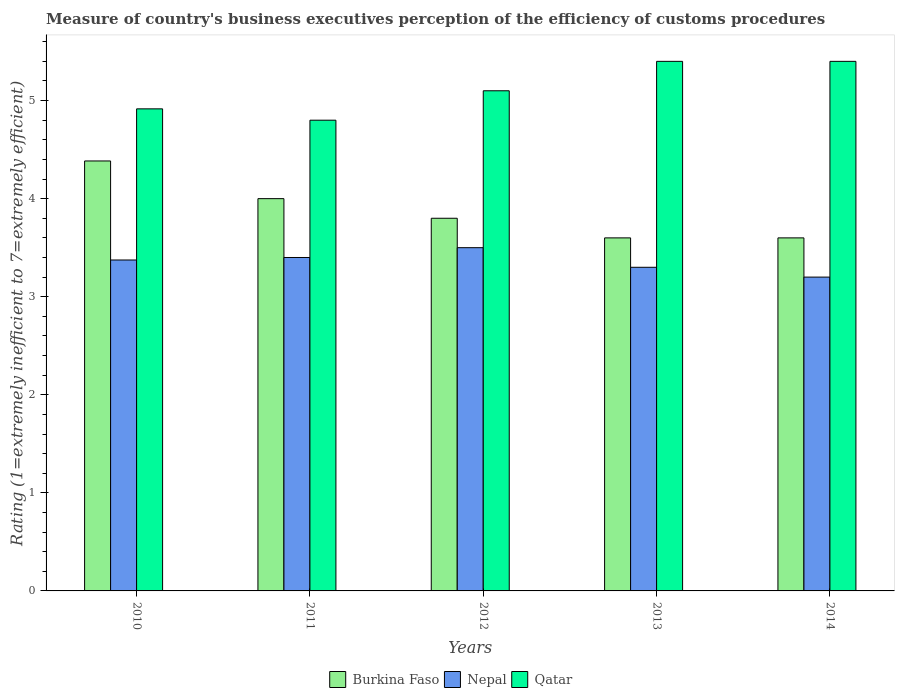How many groups of bars are there?
Provide a short and direct response. 5. How many bars are there on the 5th tick from the left?
Provide a succinct answer. 3. What is the label of the 4th group of bars from the left?
Offer a very short reply. 2013. Across all years, what is the maximum rating of the efficiency of customs procedure in Nepal?
Provide a succinct answer. 3.5. In which year was the rating of the efficiency of customs procedure in Burkina Faso maximum?
Keep it short and to the point. 2010. In which year was the rating of the efficiency of customs procedure in Qatar minimum?
Give a very brief answer. 2011. What is the total rating of the efficiency of customs procedure in Nepal in the graph?
Offer a terse response. 16.77. What is the difference between the rating of the efficiency of customs procedure in Qatar in 2011 and that in 2012?
Keep it short and to the point. -0.3. What is the difference between the rating of the efficiency of customs procedure in Qatar in 2011 and the rating of the efficiency of customs procedure in Nepal in 2010?
Ensure brevity in your answer.  1.43. What is the average rating of the efficiency of customs procedure in Qatar per year?
Your answer should be compact. 5.12. What is the ratio of the rating of the efficiency of customs procedure in Qatar in 2012 to that in 2014?
Offer a terse response. 0.94. Is the rating of the efficiency of customs procedure in Nepal in 2010 less than that in 2014?
Keep it short and to the point. No. Is the difference between the rating of the efficiency of customs procedure in Qatar in 2010 and 2013 greater than the difference between the rating of the efficiency of customs procedure in Nepal in 2010 and 2013?
Give a very brief answer. No. What is the difference between the highest and the second highest rating of the efficiency of customs procedure in Nepal?
Offer a very short reply. 0.1. What is the difference between the highest and the lowest rating of the efficiency of customs procedure in Burkina Faso?
Offer a terse response. 0.78. Is the sum of the rating of the efficiency of customs procedure in Nepal in 2010 and 2013 greater than the maximum rating of the efficiency of customs procedure in Burkina Faso across all years?
Provide a short and direct response. Yes. What does the 1st bar from the left in 2013 represents?
Give a very brief answer. Burkina Faso. What does the 3rd bar from the right in 2013 represents?
Give a very brief answer. Burkina Faso. Is it the case that in every year, the sum of the rating of the efficiency of customs procedure in Nepal and rating of the efficiency of customs procedure in Burkina Faso is greater than the rating of the efficiency of customs procedure in Qatar?
Give a very brief answer. Yes. How many bars are there?
Offer a terse response. 15. Are all the bars in the graph horizontal?
Make the answer very short. No. Are the values on the major ticks of Y-axis written in scientific E-notation?
Your answer should be compact. No. Does the graph contain grids?
Offer a very short reply. No. Where does the legend appear in the graph?
Your answer should be compact. Bottom center. How many legend labels are there?
Offer a terse response. 3. What is the title of the graph?
Your answer should be very brief. Measure of country's business executives perception of the efficiency of customs procedures. What is the label or title of the X-axis?
Your answer should be compact. Years. What is the label or title of the Y-axis?
Offer a terse response. Rating (1=extremely inefficient to 7=extremely efficient). What is the Rating (1=extremely inefficient to 7=extremely efficient) of Burkina Faso in 2010?
Give a very brief answer. 4.38. What is the Rating (1=extremely inefficient to 7=extremely efficient) of Nepal in 2010?
Provide a short and direct response. 3.37. What is the Rating (1=extremely inefficient to 7=extremely efficient) of Qatar in 2010?
Provide a short and direct response. 4.92. What is the Rating (1=extremely inefficient to 7=extremely efficient) in Burkina Faso in 2011?
Make the answer very short. 4. What is the Rating (1=extremely inefficient to 7=extremely efficient) in Nepal in 2011?
Ensure brevity in your answer.  3.4. What is the Rating (1=extremely inefficient to 7=extremely efficient) in Qatar in 2011?
Offer a very short reply. 4.8. What is the Rating (1=extremely inefficient to 7=extremely efficient) in Burkina Faso in 2012?
Your answer should be compact. 3.8. What is the Rating (1=extremely inefficient to 7=extremely efficient) in Nepal in 2012?
Keep it short and to the point. 3.5. What is the Rating (1=extremely inefficient to 7=extremely efficient) in Qatar in 2012?
Your answer should be very brief. 5.1. What is the Rating (1=extremely inefficient to 7=extremely efficient) of Qatar in 2013?
Your answer should be very brief. 5.4. What is the Rating (1=extremely inefficient to 7=extremely efficient) in Qatar in 2014?
Provide a short and direct response. 5.4. Across all years, what is the maximum Rating (1=extremely inefficient to 7=extremely efficient) of Burkina Faso?
Offer a terse response. 4.38. Across all years, what is the maximum Rating (1=extremely inefficient to 7=extremely efficient) of Nepal?
Keep it short and to the point. 3.5. Across all years, what is the maximum Rating (1=extremely inefficient to 7=extremely efficient) in Qatar?
Ensure brevity in your answer.  5.4. Across all years, what is the minimum Rating (1=extremely inefficient to 7=extremely efficient) of Qatar?
Your answer should be very brief. 4.8. What is the total Rating (1=extremely inefficient to 7=extremely efficient) in Burkina Faso in the graph?
Ensure brevity in your answer.  19.38. What is the total Rating (1=extremely inefficient to 7=extremely efficient) of Nepal in the graph?
Give a very brief answer. 16.77. What is the total Rating (1=extremely inefficient to 7=extremely efficient) of Qatar in the graph?
Provide a short and direct response. 25.62. What is the difference between the Rating (1=extremely inefficient to 7=extremely efficient) of Burkina Faso in 2010 and that in 2011?
Keep it short and to the point. 0.38. What is the difference between the Rating (1=extremely inefficient to 7=extremely efficient) in Nepal in 2010 and that in 2011?
Make the answer very short. -0.03. What is the difference between the Rating (1=extremely inefficient to 7=extremely efficient) in Qatar in 2010 and that in 2011?
Give a very brief answer. 0.12. What is the difference between the Rating (1=extremely inefficient to 7=extremely efficient) of Burkina Faso in 2010 and that in 2012?
Offer a terse response. 0.58. What is the difference between the Rating (1=extremely inefficient to 7=extremely efficient) in Nepal in 2010 and that in 2012?
Offer a terse response. -0.13. What is the difference between the Rating (1=extremely inefficient to 7=extremely efficient) of Qatar in 2010 and that in 2012?
Offer a very short reply. -0.18. What is the difference between the Rating (1=extremely inefficient to 7=extremely efficient) in Burkina Faso in 2010 and that in 2013?
Your response must be concise. 0.78. What is the difference between the Rating (1=extremely inefficient to 7=extremely efficient) of Nepal in 2010 and that in 2013?
Your response must be concise. 0.07. What is the difference between the Rating (1=extremely inefficient to 7=extremely efficient) in Qatar in 2010 and that in 2013?
Provide a short and direct response. -0.48. What is the difference between the Rating (1=extremely inefficient to 7=extremely efficient) of Burkina Faso in 2010 and that in 2014?
Give a very brief answer. 0.78. What is the difference between the Rating (1=extremely inefficient to 7=extremely efficient) of Nepal in 2010 and that in 2014?
Give a very brief answer. 0.17. What is the difference between the Rating (1=extremely inefficient to 7=extremely efficient) in Qatar in 2010 and that in 2014?
Keep it short and to the point. -0.48. What is the difference between the Rating (1=extremely inefficient to 7=extremely efficient) of Burkina Faso in 2011 and that in 2012?
Keep it short and to the point. 0.2. What is the difference between the Rating (1=extremely inefficient to 7=extremely efficient) of Nepal in 2011 and that in 2012?
Keep it short and to the point. -0.1. What is the difference between the Rating (1=extremely inefficient to 7=extremely efficient) of Burkina Faso in 2011 and that in 2013?
Your answer should be compact. 0.4. What is the difference between the Rating (1=extremely inefficient to 7=extremely efficient) of Nepal in 2011 and that in 2013?
Ensure brevity in your answer.  0.1. What is the difference between the Rating (1=extremely inefficient to 7=extremely efficient) in Burkina Faso in 2011 and that in 2014?
Provide a short and direct response. 0.4. What is the difference between the Rating (1=extremely inefficient to 7=extremely efficient) of Nepal in 2011 and that in 2014?
Offer a very short reply. 0.2. What is the difference between the Rating (1=extremely inefficient to 7=extremely efficient) in Qatar in 2011 and that in 2014?
Give a very brief answer. -0.6. What is the difference between the Rating (1=extremely inefficient to 7=extremely efficient) in Burkina Faso in 2012 and that in 2013?
Make the answer very short. 0.2. What is the difference between the Rating (1=extremely inefficient to 7=extremely efficient) of Nepal in 2012 and that in 2013?
Provide a succinct answer. 0.2. What is the difference between the Rating (1=extremely inefficient to 7=extremely efficient) in Qatar in 2012 and that in 2013?
Your answer should be compact. -0.3. What is the difference between the Rating (1=extremely inefficient to 7=extremely efficient) of Burkina Faso in 2012 and that in 2014?
Make the answer very short. 0.2. What is the difference between the Rating (1=extremely inefficient to 7=extremely efficient) in Qatar in 2013 and that in 2014?
Give a very brief answer. 0. What is the difference between the Rating (1=extremely inefficient to 7=extremely efficient) of Burkina Faso in 2010 and the Rating (1=extremely inefficient to 7=extremely efficient) of Nepal in 2011?
Offer a very short reply. 0.98. What is the difference between the Rating (1=extremely inefficient to 7=extremely efficient) of Burkina Faso in 2010 and the Rating (1=extremely inefficient to 7=extremely efficient) of Qatar in 2011?
Provide a short and direct response. -0.42. What is the difference between the Rating (1=extremely inefficient to 7=extremely efficient) in Nepal in 2010 and the Rating (1=extremely inefficient to 7=extremely efficient) in Qatar in 2011?
Offer a terse response. -1.43. What is the difference between the Rating (1=extremely inefficient to 7=extremely efficient) of Burkina Faso in 2010 and the Rating (1=extremely inefficient to 7=extremely efficient) of Nepal in 2012?
Your response must be concise. 0.88. What is the difference between the Rating (1=extremely inefficient to 7=extremely efficient) in Burkina Faso in 2010 and the Rating (1=extremely inefficient to 7=extremely efficient) in Qatar in 2012?
Make the answer very short. -0.72. What is the difference between the Rating (1=extremely inefficient to 7=extremely efficient) in Nepal in 2010 and the Rating (1=extremely inefficient to 7=extremely efficient) in Qatar in 2012?
Offer a very short reply. -1.73. What is the difference between the Rating (1=extremely inefficient to 7=extremely efficient) of Burkina Faso in 2010 and the Rating (1=extremely inefficient to 7=extremely efficient) of Nepal in 2013?
Keep it short and to the point. 1.08. What is the difference between the Rating (1=extremely inefficient to 7=extremely efficient) in Burkina Faso in 2010 and the Rating (1=extremely inefficient to 7=extremely efficient) in Qatar in 2013?
Your answer should be compact. -1.02. What is the difference between the Rating (1=extremely inefficient to 7=extremely efficient) in Nepal in 2010 and the Rating (1=extremely inefficient to 7=extremely efficient) in Qatar in 2013?
Provide a short and direct response. -2.03. What is the difference between the Rating (1=extremely inefficient to 7=extremely efficient) of Burkina Faso in 2010 and the Rating (1=extremely inefficient to 7=extremely efficient) of Nepal in 2014?
Your answer should be compact. 1.18. What is the difference between the Rating (1=extremely inefficient to 7=extremely efficient) of Burkina Faso in 2010 and the Rating (1=extremely inefficient to 7=extremely efficient) of Qatar in 2014?
Make the answer very short. -1.02. What is the difference between the Rating (1=extremely inefficient to 7=extremely efficient) in Nepal in 2010 and the Rating (1=extremely inefficient to 7=extremely efficient) in Qatar in 2014?
Make the answer very short. -2.03. What is the difference between the Rating (1=extremely inefficient to 7=extremely efficient) of Burkina Faso in 2011 and the Rating (1=extremely inefficient to 7=extremely efficient) of Nepal in 2012?
Give a very brief answer. 0.5. What is the difference between the Rating (1=extremely inefficient to 7=extremely efficient) in Nepal in 2011 and the Rating (1=extremely inefficient to 7=extremely efficient) in Qatar in 2012?
Your response must be concise. -1.7. What is the difference between the Rating (1=extremely inefficient to 7=extremely efficient) of Burkina Faso in 2011 and the Rating (1=extremely inefficient to 7=extremely efficient) of Nepal in 2013?
Your response must be concise. 0.7. What is the difference between the Rating (1=extremely inefficient to 7=extremely efficient) in Burkina Faso in 2011 and the Rating (1=extremely inefficient to 7=extremely efficient) in Qatar in 2013?
Give a very brief answer. -1.4. What is the difference between the Rating (1=extremely inefficient to 7=extremely efficient) in Nepal in 2011 and the Rating (1=extremely inefficient to 7=extremely efficient) in Qatar in 2013?
Ensure brevity in your answer.  -2. What is the difference between the Rating (1=extremely inefficient to 7=extremely efficient) in Burkina Faso in 2012 and the Rating (1=extremely inefficient to 7=extremely efficient) in Qatar in 2013?
Make the answer very short. -1.6. What is the difference between the Rating (1=extremely inefficient to 7=extremely efficient) of Burkina Faso in 2013 and the Rating (1=extremely inefficient to 7=extremely efficient) of Nepal in 2014?
Ensure brevity in your answer.  0.4. What is the difference between the Rating (1=extremely inefficient to 7=extremely efficient) of Burkina Faso in 2013 and the Rating (1=extremely inefficient to 7=extremely efficient) of Qatar in 2014?
Provide a short and direct response. -1.8. What is the average Rating (1=extremely inefficient to 7=extremely efficient) in Burkina Faso per year?
Provide a succinct answer. 3.88. What is the average Rating (1=extremely inefficient to 7=extremely efficient) in Nepal per year?
Your answer should be compact. 3.35. What is the average Rating (1=extremely inefficient to 7=extremely efficient) in Qatar per year?
Give a very brief answer. 5.12. In the year 2010, what is the difference between the Rating (1=extremely inefficient to 7=extremely efficient) of Burkina Faso and Rating (1=extremely inefficient to 7=extremely efficient) of Nepal?
Offer a very short reply. 1.01. In the year 2010, what is the difference between the Rating (1=extremely inefficient to 7=extremely efficient) of Burkina Faso and Rating (1=extremely inefficient to 7=extremely efficient) of Qatar?
Your answer should be compact. -0.53. In the year 2010, what is the difference between the Rating (1=extremely inefficient to 7=extremely efficient) in Nepal and Rating (1=extremely inefficient to 7=extremely efficient) in Qatar?
Provide a succinct answer. -1.54. In the year 2011, what is the difference between the Rating (1=extremely inefficient to 7=extremely efficient) of Nepal and Rating (1=extremely inefficient to 7=extremely efficient) of Qatar?
Your answer should be compact. -1.4. In the year 2012, what is the difference between the Rating (1=extremely inefficient to 7=extremely efficient) of Burkina Faso and Rating (1=extremely inefficient to 7=extremely efficient) of Qatar?
Your response must be concise. -1.3. In the year 2012, what is the difference between the Rating (1=extremely inefficient to 7=extremely efficient) in Nepal and Rating (1=extremely inefficient to 7=extremely efficient) in Qatar?
Ensure brevity in your answer.  -1.6. In the year 2013, what is the difference between the Rating (1=extremely inefficient to 7=extremely efficient) of Burkina Faso and Rating (1=extremely inefficient to 7=extremely efficient) of Nepal?
Your answer should be compact. 0.3. In the year 2013, what is the difference between the Rating (1=extremely inefficient to 7=extremely efficient) in Nepal and Rating (1=extremely inefficient to 7=extremely efficient) in Qatar?
Offer a very short reply. -2.1. In the year 2014, what is the difference between the Rating (1=extremely inefficient to 7=extremely efficient) of Nepal and Rating (1=extremely inefficient to 7=extremely efficient) of Qatar?
Your answer should be very brief. -2.2. What is the ratio of the Rating (1=extremely inefficient to 7=extremely efficient) of Burkina Faso in 2010 to that in 2011?
Give a very brief answer. 1.1. What is the ratio of the Rating (1=extremely inefficient to 7=extremely efficient) of Qatar in 2010 to that in 2011?
Give a very brief answer. 1.02. What is the ratio of the Rating (1=extremely inefficient to 7=extremely efficient) in Burkina Faso in 2010 to that in 2012?
Your answer should be very brief. 1.15. What is the ratio of the Rating (1=extremely inefficient to 7=extremely efficient) in Nepal in 2010 to that in 2012?
Give a very brief answer. 0.96. What is the ratio of the Rating (1=extremely inefficient to 7=extremely efficient) of Qatar in 2010 to that in 2012?
Provide a short and direct response. 0.96. What is the ratio of the Rating (1=extremely inefficient to 7=extremely efficient) in Burkina Faso in 2010 to that in 2013?
Give a very brief answer. 1.22. What is the ratio of the Rating (1=extremely inefficient to 7=extremely efficient) in Nepal in 2010 to that in 2013?
Ensure brevity in your answer.  1.02. What is the ratio of the Rating (1=extremely inefficient to 7=extremely efficient) of Qatar in 2010 to that in 2013?
Offer a very short reply. 0.91. What is the ratio of the Rating (1=extremely inefficient to 7=extremely efficient) of Burkina Faso in 2010 to that in 2014?
Your answer should be very brief. 1.22. What is the ratio of the Rating (1=extremely inefficient to 7=extremely efficient) of Nepal in 2010 to that in 2014?
Make the answer very short. 1.05. What is the ratio of the Rating (1=extremely inefficient to 7=extremely efficient) in Qatar in 2010 to that in 2014?
Give a very brief answer. 0.91. What is the ratio of the Rating (1=extremely inefficient to 7=extremely efficient) in Burkina Faso in 2011 to that in 2012?
Give a very brief answer. 1.05. What is the ratio of the Rating (1=extremely inefficient to 7=extremely efficient) of Nepal in 2011 to that in 2012?
Make the answer very short. 0.97. What is the ratio of the Rating (1=extremely inefficient to 7=extremely efficient) in Nepal in 2011 to that in 2013?
Make the answer very short. 1.03. What is the ratio of the Rating (1=extremely inefficient to 7=extremely efficient) in Qatar in 2011 to that in 2014?
Keep it short and to the point. 0.89. What is the ratio of the Rating (1=extremely inefficient to 7=extremely efficient) of Burkina Faso in 2012 to that in 2013?
Provide a succinct answer. 1.06. What is the ratio of the Rating (1=extremely inefficient to 7=extremely efficient) of Nepal in 2012 to that in 2013?
Ensure brevity in your answer.  1.06. What is the ratio of the Rating (1=extremely inefficient to 7=extremely efficient) of Qatar in 2012 to that in 2013?
Keep it short and to the point. 0.94. What is the ratio of the Rating (1=extremely inefficient to 7=extremely efficient) of Burkina Faso in 2012 to that in 2014?
Ensure brevity in your answer.  1.06. What is the ratio of the Rating (1=extremely inefficient to 7=extremely efficient) of Nepal in 2012 to that in 2014?
Give a very brief answer. 1.09. What is the ratio of the Rating (1=extremely inefficient to 7=extremely efficient) in Qatar in 2012 to that in 2014?
Make the answer very short. 0.94. What is the ratio of the Rating (1=extremely inefficient to 7=extremely efficient) in Burkina Faso in 2013 to that in 2014?
Your answer should be compact. 1. What is the ratio of the Rating (1=extremely inefficient to 7=extremely efficient) of Nepal in 2013 to that in 2014?
Offer a terse response. 1.03. What is the difference between the highest and the second highest Rating (1=extremely inefficient to 7=extremely efficient) of Burkina Faso?
Provide a short and direct response. 0.38. What is the difference between the highest and the second highest Rating (1=extremely inefficient to 7=extremely efficient) in Qatar?
Make the answer very short. 0. What is the difference between the highest and the lowest Rating (1=extremely inefficient to 7=extremely efficient) in Burkina Faso?
Your answer should be compact. 0.78. 